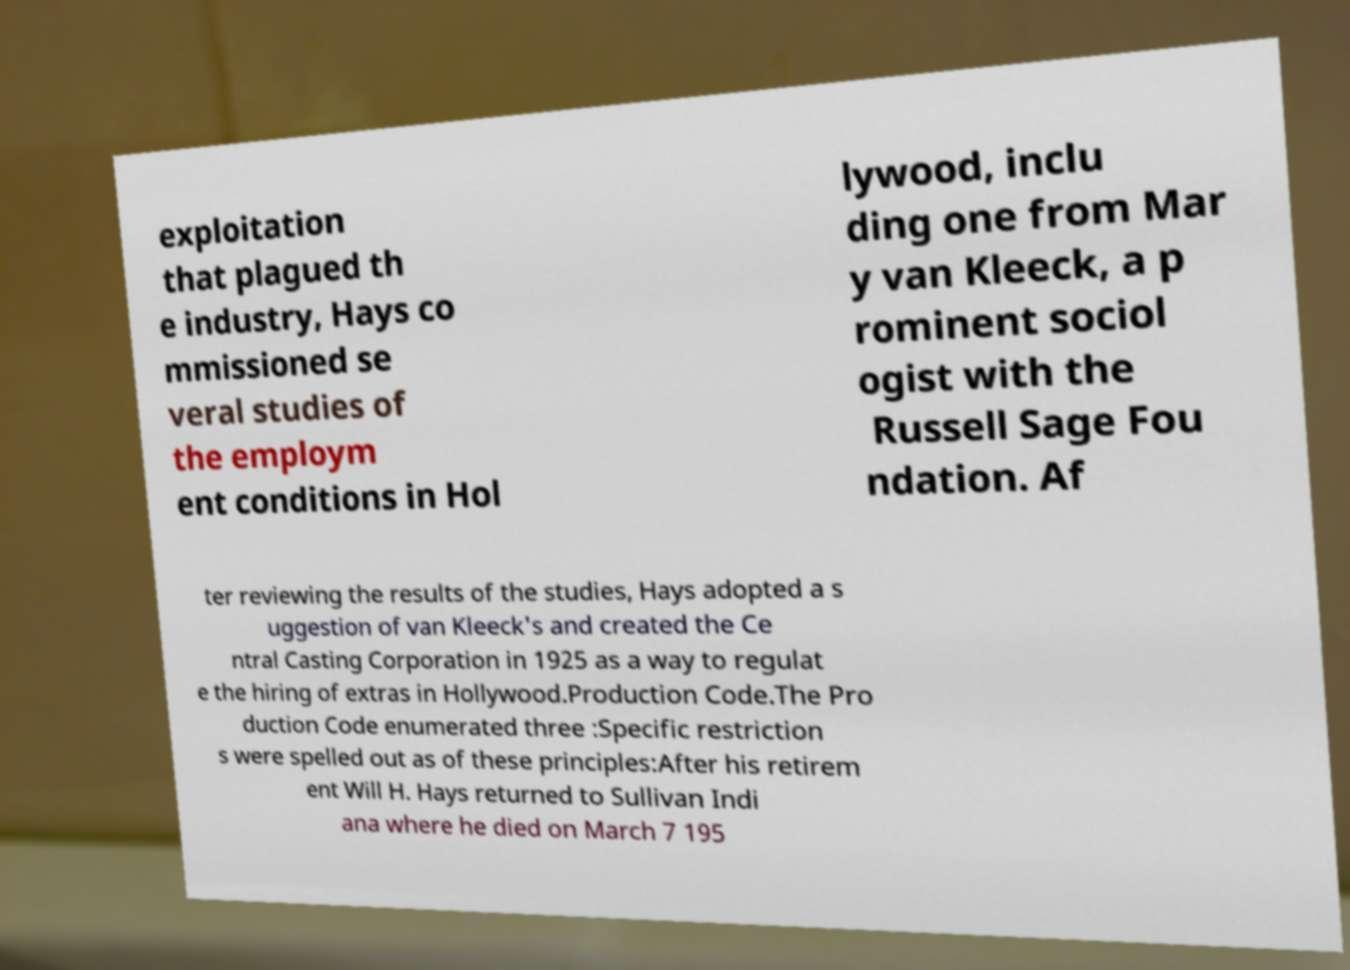Please identify and transcribe the text found in this image. exploitation that plagued th e industry, Hays co mmissioned se veral studies of the employm ent conditions in Hol lywood, inclu ding one from Mar y van Kleeck, a p rominent sociol ogist with the Russell Sage Fou ndation. Af ter reviewing the results of the studies, Hays adopted a s uggestion of van Kleeck's and created the Ce ntral Casting Corporation in 1925 as a way to regulat e the hiring of extras in Hollywood.Production Code.The Pro duction Code enumerated three :Specific restriction s were spelled out as of these principles:After his retirem ent Will H. Hays returned to Sullivan Indi ana where he died on March 7 195 